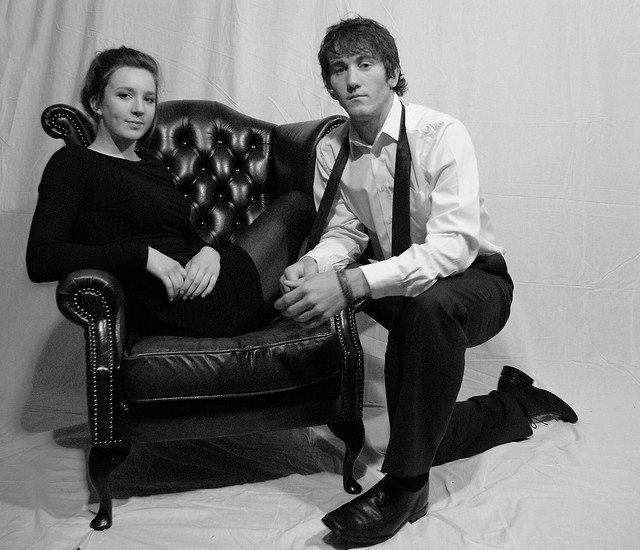<image>Is she going to tie his tie? No, she is not going to tie his tie. Is she going to tie his tie? I don't know if she is going to tie his tie. All the answers suggest that she is not going to tie his tie. 